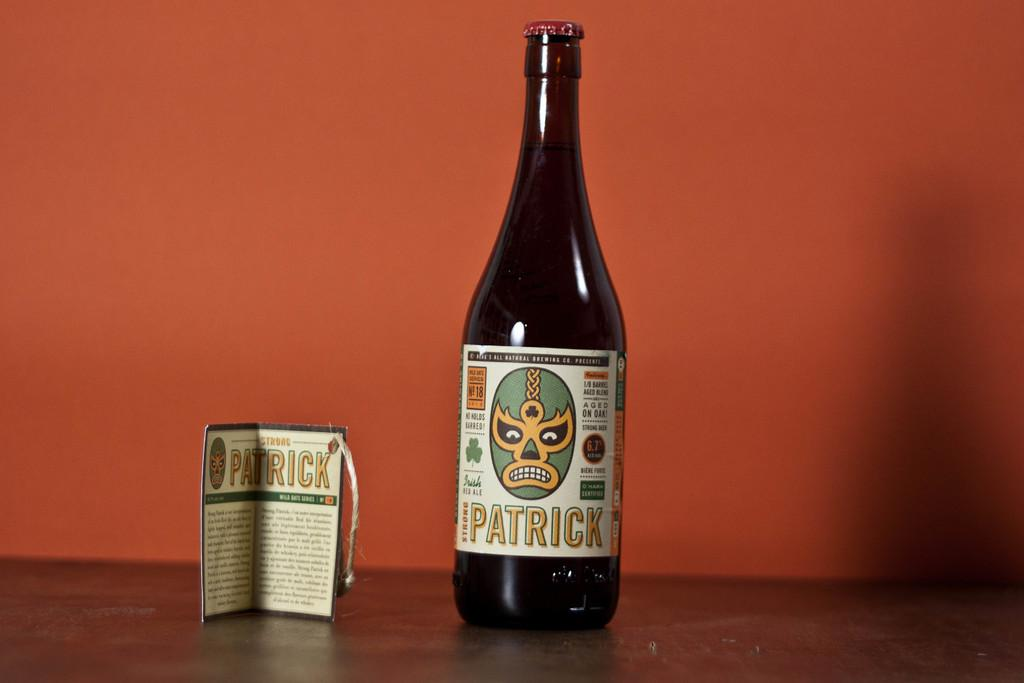<image>
Relay a brief, clear account of the picture shown. a bottle of Patrick with a label and against an orange backdrop 